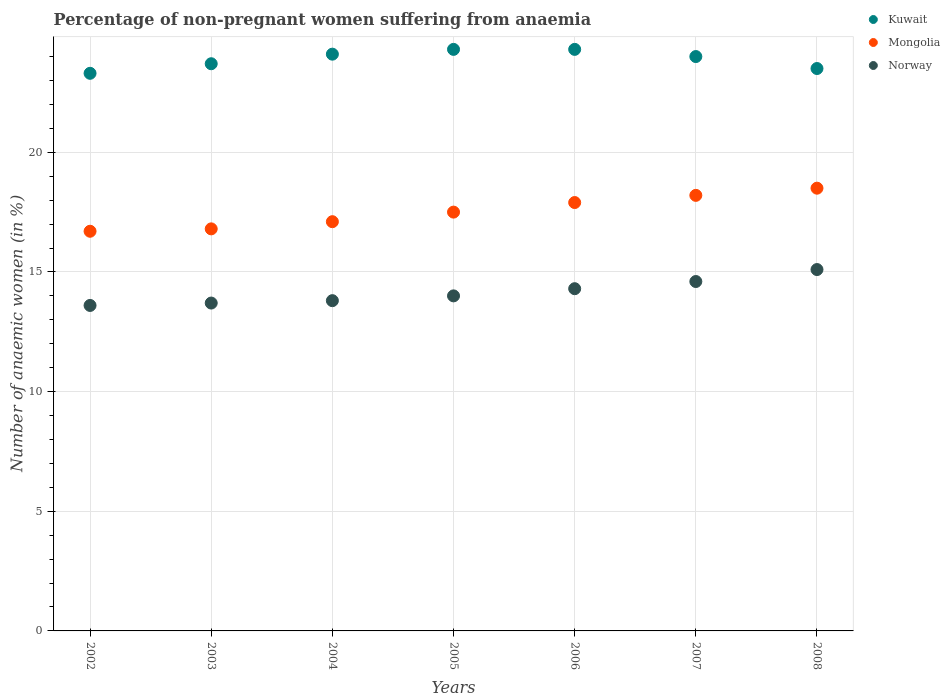How many different coloured dotlines are there?
Your answer should be very brief. 3. Is the number of dotlines equal to the number of legend labels?
Give a very brief answer. Yes. Across all years, what is the minimum percentage of non-pregnant women suffering from anaemia in Norway?
Provide a succinct answer. 13.6. In which year was the percentage of non-pregnant women suffering from anaemia in Mongolia minimum?
Your answer should be compact. 2002. What is the total percentage of non-pregnant women suffering from anaemia in Kuwait in the graph?
Your response must be concise. 167.2. What is the difference between the percentage of non-pregnant women suffering from anaemia in Norway in 2002 and that in 2004?
Your response must be concise. -0.2. What is the difference between the percentage of non-pregnant women suffering from anaemia in Kuwait in 2002 and the percentage of non-pregnant women suffering from anaemia in Norway in 2003?
Offer a terse response. 9.6. What is the average percentage of non-pregnant women suffering from anaemia in Kuwait per year?
Offer a very short reply. 23.89. In the year 2008, what is the difference between the percentage of non-pregnant women suffering from anaemia in Norway and percentage of non-pregnant women suffering from anaemia in Kuwait?
Offer a terse response. -8.4. What is the ratio of the percentage of non-pregnant women suffering from anaemia in Kuwait in 2002 to that in 2003?
Ensure brevity in your answer.  0.98. In how many years, is the percentage of non-pregnant women suffering from anaemia in Norway greater than the average percentage of non-pregnant women suffering from anaemia in Norway taken over all years?
Keep it short and to the point. 3. Is the sum of the percentage of non-pregnant women suffering from anaemia in Norway in 2007 and 2008 greater than the maximum percentage of non-pregnant women suffering from anaemia in Mongolia across all years?
Make the answer very short. Yes. Does the percentage of non-pregnant women suffering from anaemia in Kuwait monotonically increase over the years?
Your answer should be compact. No. How many dotlines are there?
Offer a terse response. 3. What is the difference between two consecutive major ticks on the Y-axis?
Provide a succinct answer. 5. Are the values on the major ticks of Y-axis written in scientific E-notation?
Your answer should be very brief. No. Where does the legend appear in the graph?
Your answer should be very brief. Top right. What is the title of the graph?
Keep it short and to the point. Percentage of non-pregnant women suffering from anaemia. What is the label or title of the X-axis?
Keep it short and to the point. Years. What is the label or title of the Y-axis?
Your answer should be very brief. Number of anaemic women (in %). What is the Number of anaemic women (in %) of Kuwait in 2002?
Offer a terse response. 23.3. What is the Number of anaemic women (in %) in Mongolia in 2002?
Your response must be concise. 16.7. What is the Number of anaemic women (in %) of Kuwait in 2003?
Offer a very short reply. 23.7. What is the Number of anaemic women (in %) of Kuwait in 2004?
Offer a terse response. 24.1. What is the Number of anaemic women (in %) of Norway in 2004?
Offer a terse response. 13.8. What is the Number of anaemic women (in %) in Kuwait in 2005?
Give a very brief answer. 24.3. What is the Number of anaemic women (in %) of Kuwait in 2006?
Keep it short and to the point. 24.3. What is the Number of anaemic women (in %) of Mongolia in 2006?
Your response must be concise. 17.9. What is the Number of anaemic women (in %) of Kuwait in 2007?
Your answer should be very brief. 24. What is the Number of anaemic women (in %) of Norway in 2008?
Keep it short and to the point. 15.1. Across all years, what is the maximum Number of anaemic women (in %) of Kuwait?
Offer a very short reply. 24.3. Across all years, what is the maximum Number of anaemic women (in %) in Mongolia?
Give a very brief answer. 18.5. Across all years, what is the maximum Number of anaemic women (in %) in Norway?
Ensure brevity in your answer.  15.1. Across all years, what is the minimum Number of anaemic women (in %) in Kuwait?
Offer a very short reply. 23.3. Across all years, what is the minimum Number of anaemic women (in %) of Mongolia?
Offer a very short reply. 16.7. What is the total Number of anaemic women (in %) of Kuwait in the graph?
Keep it short and to the point. 167.2. What is the total Number of anaemic women (in %) of Mongolia in the graph?
Offer a terse response. 122.7. What is the total Number of anaemic women (in %) in Norway in the graph?
Your response must be concise. 99.1. What is the difference between the Number of anaemic women (in %) of Norway in 2002 and that in 2003?
Offer a terse response. -0.1. What is the difference between the Number of anaemic women (in %) of Mongolia in 2002 and that in 2005?
Offer a terse response. -0.8. What is the difference between the Number of anaemic women (in %) in Norway in 2002 and that in 2005?
Offer a very short reply. -0.4. What is the difference between the Number of anaemic women (in %) of Kuwait in 2002 and that in 2006?
Give a very brief answer. -1. What is the difference between the Number of anaemic women (in %) of Kuwait in 2002 and that in 2007?
Make the answer very short. -0.7. What is the difference between the Number of anaemic women (in %) in Norway in 2002 and that in 2007?
Your answer should be very brief. -1. What is the difference between the Number of anaemic women (in %) of Kuwait in 2002 and that in 2008?
Make the answer very short. -0.2. What is the difference between the Number of anaemic women (in %) of Norway in 2002 and that in 2008?
Your answer should be very brief. -1.5. What is the difference between the Number of anaemic women (in %) in Kuwait in 2003 and that in 2004?
Your answer should be very brief. -0.4. What is the difference between the Number of anaemic women (in %) of Mongolia in 2003 and that in 2004?
Offer a terse response. -0.3. What is the difference between the Number of anaemic women (in %) of Kuwait in 2003 and that in 2005?
Your answer should be very brief. -0.6. What is the difference between the Number of anaemic women (in %) in Mongolia in 2003 and that in 2005?
Your answer should be very brief. -0.7. What is the difference between the Number of anaemic women (in %) in Norway in 2003 and that in 2005?
Your answer should be compact. -0.3. What is the difference between the Number of anaemic women (in %) of Mongolia in 2003 and that in 2007?
Your response must be concise. -1.4. What is the difference between the Number of anaemic women (in %) in Norway in 2003 and that in 2007?
Provide a succinct answer. -0.9. What is the difference between the Number of anaemic women (in %) in Kuwait in 2004 and that in 2005?
Ensure brevity in your answer.  -0.2. What is the difference between the Number of anaemic women (in %) of Mongolia in 2004 and that in 2005?
Provide a short and direct response. -0.4. What is the difference between the Number of anaemic women (in %) of Norway in 2004 and that in 2006?
Provide a succinct answer. -0.5. What is the difference between the Number of anaemic women (in %) of Kuwait in 2004 and that in 2007?
Make the answer very short. 0.1. What is the difference between the Number of anaemic women (in %) of Mongolia in 2005 and that in 2006?
Give a very brief answer. -0.4. What is the difference between the Number of anaemic women (in %) in Norway in 2005 and that in 2006?
Provide a succinct answer. -0.3. What is the difference between the Number of anaemic women (in %) of Kuwait in 2005 and that in 2007?
Provide a short and direct response. 0.3. What is the difference between the Number of anaemic women (in %) in Mongolia in 2005 and that in 2007?
Your answer should be very brief. -0.7. What is the difference between the Number of anaemic women (in %) of Norway in 2005 and that in 2007?
Offer a terse response. -0.6. What is the difference between the Number of anaemic women (in %) in Mongolia in 2005 and that in 2008?
Offer a very short reply. -1. What is the difference between the Number of anaemic women (in %) of Kuwait in 2006 and that in 2008?
Provide a short and direct response. 0.8. What is the difference between the Number of anaemic women (in %) of Mongolia in 2006 and that in 2008?
Ensure brevity in your answer.  -0.6. What is the difference between the Number of anaemic women (in %) of Norway in 2006 and that in 2008?
Ensure brevity in your answer.  -0.8. What is the difference between the Number of anaemic women (in %) in Norway in 2007 and that in 2008?
Give a very brief answer. -0.5. What is the difference between the Number of anaemic women (in %) in Kuwait in 2002 and the Number of anaemic women (in %) in Norway in 2004?
Provide a succinct answer. 9.5. What is the difference between the Number of anaemic women (in %) in Mongolia in 2002 and the Number of anaemic women (in %) in Norway in 2004?
Give a very brief answer. 2.9. What is the difference between the Number of anaemic women (in %) of Kuwait in 2002 and the Number of anaemic women (in %) of Mongolia in 2005?
Your answer should be very brief. 5.8. What is the difference between the Number of anaemic women (in %) of Kuwait in 2002 and the Number of anaemic women (in %) of Norway in 2005?
Your response must be concise. 9.3. What is the difference between the Number of anaemic women (in %) in Kuwait in 2002 and the Number of anaemic women (in %) in Mongolia in 2006?
Give a very brief answer. 5.4. What is the difference between the Number of anaemic women (in %) of Mongolia in 2002 and the Number of anaemic women (in %) of Norway in 2006?
Your answer should be compact. 2.4. What is the difference between the Number of anaemic women (in %) of Kuwait in 2002 and the Number of anaemic women (in %) of Mongolia in 2007?
Provide a short and direct response. 5.1. What is the difference between the Number of anaemic women (in %) of Kuwait in 2002 and the Number of anaemic women (in %) of Norway in 2007?
Make the answer very short. 8.7. What is the difference between the Number of anaemic women (in %) in Mongolia in 2002 and the Number of anaemic women (in %) in Norway in 2007?
Provide a succinct answer. 2.1. What is the difference between the Number of anaemic women (in %) of Kuwait in 2002 and the Number of anaemic women (in %) of Mongolia in 2008?
Your response must be concise. 4.8. What is the difference between the Number of anaemic women (in %) of Kuwait in 2003 and the Number of anaemic women (in %) of Norway in 2004?
Provide a short and direct response. 9.9. What is the difference between the Number of anaemic women (in %) in Kuwait in 2003 and the Number of anaemic women (in %) in Mongolia in 2005?
Provide a short and direct response. 6.2. What is the difference between the Number of anaemic women (in %) of Mongolia in 2003 and the Number of anaemic women (in %) of Norway in 2005?
Offer a terse response. 2.8. What is the difference between the Number of anaemic women (in %) in Kuwait in 2003 and the Number of anaemic women (in %) in Norway in 2006?
Offer a terse response. 9.4. What is the difference between the Number of anaemic women (in %) in Mongolia in 2003 and the Number of anaemic women (in %) in Norway in 2006?
Your response must be concise. 2.5. What is the difference between the Number of anaemic women (in %) of Mongolia in 2003 and the Number of anaemic women (in %) of Norway in 2007?
Your answer should be compact. 2.2. What is the difference between the Number of anaemic women (in %) in Kuwait in 2003 and the Number of anaemic women (in %) in Mongolia in 2008?
Ensure brevity in your answer.  5.2. What is the difference between the Number of anaemic women (in %) in Mongolia in 2003 and the Number of anaemic women (in %) in Norway in 2008?
Keep it short and to the point. 1.7. What is the difference between the Number of anaemic women (in %) of Kuwait in 2004 and the Number of anaemic women (in %) of Mongolia in 2005?
Provide a short and direct response. 6.6. What is the difference between the Number of anaemic women (in %) of Kuwait in 2004 and the Number of anaemic women (in %) of Mongolia in 2006?
Make the answer very short. 6.2. What is the difference between the Number of anaemic women (in %) of Mongolia in 2004 and the Number of anaemic women (in %) of Norway in 2006?
Offer a very short reply. 2.8. What is the difference between the Number of anaemic women (in %) in Kuwait in 2004 and the Number of anaemic women (in %) in Mongolia in 2007?
Provide a succinct answer. 5.9. What is the difference between the Number of anaemic women (in %) in Kuwait in 2004 and the Number of anaemic women (in %) in Mongolia in 2008?
Offer a terse response. 5.6. What is the difference between the Number of anaemic women (in %) of Kuwait in 2004 and the Number of anaemic women (in %) of Norway in 2008?
Keep it short and to the point. 9. What is the difference between the Number of anaemic women (in %) of Kuwait in 2005 and the Number of anaemic women (in %) of Mongolia in 2007?
Your answer should be very brief. 6.1. What is the difference between the Number of anaemic women (in %) of Kuwait in 2005 and the Number of anaemic women (in %) of Mongolia in 2008?
Provide a short and direct response. 5.8. What is the difference between the Number of anaemic women (in %) in Kuwait in 2005 and the Number of anaemic women (in %) in Norway in 2008?
Your answer should be very brief. 9.2. What is the difference between the Number of anaemic women (in %) in Mongolia in 2006 and the Number of anaemic women (in %) in Norway in 2007?
Your answer should be compact. 3.3. What is the difference between the Number of anaemic women (in %) of Kuwait in 2006 and the Number of anaemic women (in %) of Mongolia in 2008?
Your answer should be very brief. 5.8. What is the difference between the Number of anaemic women (in %) in Mongolia in 2006 and the Number of anaemic women (in %) in Norway in 2008?
Offer a terse response. 2.8. What is the difference between the Number of anaemic women (in %) of Kuwait in 2007 and the Number of anaemic women (in %) of Mongolia in 2008?
Your answer should be very brief. 5.5. What is the difference between the Number of anaemic women (in %) of Kuwait in 2007 and the Number of anaemic women (in %) of Norway in 2008?
Offer a very short reply. 8.9. What is the average Number of anaemic women (in %) in Kuwait per year?
Your response must be concise. 23.89. What is the average Number of anaemic women (in %) of Mongolia per year?
Your response must be concise. 17.53. What is the average Number of anaemic women (in %) of Norway per year?
Ensure brevity in your answer.  14.16. In the year 2002, what is the difference between the Number of anaemic women (in %) of Kuwait and Number of anaemic women (in %) of Mongolia?
Offer a terse response. 6.6. In the year 2003, what is the difference between the Number of anaemic women (in %) in Kuwait and Number of anaemic women (in %) in Mongolia?
Ensure brevity in your answer.  6.9. In the year 2003, what is the difference between the Number of anaemic women (in %) in Mongolia and Number of anaemic women (in %) in Norway?
Make the answer very short. 3.1. In the year 2004, what is the difference between the Number of anaemic women (in %) in Kuwait and Number of anaemic women (in %) in Norway?
Your answer should be very brief. 10.3. In the year 2004, what is the difference between the Number of anaemic women (in %) in Mongolia and Number of anaemic women (in %) in Norway?
Provide a short and direct response. 3.3. In the year 2005, what is the difference between the Number of anaemic women (in %) of Kuwait and Number of anaemic women (in %) of Mongolia?
Provide a short and direct response. 6.8. In the year 2005, what is the difference between the Number of anaemic women (in %) of Kuwait and Number of anaemic women (in %) of Norway?
Keep it short and to the point. 10.3. In the year 2006, what is the difference between the Number of anaemic women (in %) in Mongolia and Number of anaemic women (in %) in Norway?
Your answer should be very brief. 3.6. In the year 2007, what is the difference between the Number of anaemic women (in %) of Kuwait and Number of anaemic women (in %) of Mongolia?
Make the answer very short. 5.8. In the year 2008, what is the difference between the Number of anaemic women (in %) of Kuwait and Number of anaemic women (in %) of Norway?
Provide a short and direct response. 8.4. In the year 2008, what is the difference between the Number of anaemic women (in %) of Mongolia and Number of anaemic women (in %) of Norway?
Give a very brief answer. 3.4. What is the ratio of the Number of anaemic women (in %) of Kuwait in 2002 to that in 2003?
Your response must be concise. 0.98. What is the ratio of the Number of anaemic women (in %) of Mongolia in 2002 to that in 2003?
Offer a terse response. 0.99. What is the ratio of the Number of anaemic women (in %) in Kuwait in 2002 to that in 2004?
Ensure brevity in your answer.  0.97. What is the ratio of the Number of anaemic women (in %) of Mongolia in 2002 to that in 2004?
Your answer should be very brief. 0.98. What is the ratio of the Number of anaemic women (in %) of Norway in 2002 to that in 2004?
Provide a short and direct response. 0.99. What is the ratio of the Number of anaemic women (in %) in Kuwait in 2002 to that in 2005?
Offer a terse response. 0.96. What is the ratio of the Number of anaemic women (in %) in Mongolia in 2002 to that in 2005?
Give a very brief answer. 0.95. What is the ratio of the Number of anaemic women (in %) of Norway in 2002 to that in 2005?
Provide a succinct answer. 0.97. What is the ratio of the Number of anaemic women (in %) in Kuwait in 2002 to that in 2006?
Provide a succinct answer. 0.96. What is the ratio of the Number of anaemic women (in %) of Mongolia in 2002 to that in 2006?
Your answer should be compact. 0.93. What is the ratio of the Number of anaemic women (in %) of Norway in 2002 to that in 2006?
Offer a very short reply. 0.95. What is the ratio of the Number of anaemic women (in %) of Kuwait in 2002 to that in 2007?
Provide a short and direct response. 0.97. What is the ratio of the Number of anaemic women (in %) in Mongolia in 2002 to that in 2007?
Ensure brevity in your answer.  0.92. What is the ratio of the Number of anaemic women (in %) of Norway in 2002 to that in 2007?
Provide a short and direct response. 0.93. What is the ratio of the Number of anaemic women (in %) in Kuwait in 2002 to that in 2008?
Ensure brevity in your answer.  0.99. What is the ratio of the Number of anaemic women (in %) of Mongolia in 2002 to that in 2008?
Provide a short and direct response. 0.9. What is the ratio of the Number of anaemic women (in %) of Norway in 2002 to that in 2008?
Offer a very short reply. 0.9. What is the ratio of the Number of anaemic women (in %) of Kuwait in 2003 to that in 2004?
Give a very brief answer. 0.98. What is the ratio of the Number of anaemic women (in %) of Mongolia in 2003 to that in 2004?
Your answer should be very brief. 0.98. What is the ratio of the Number of anaemic women (in %) in Norway in 2003 to that in 2004?
Offer a terse response. 0.99. What is the ratio of the Number of anaemic women (in %) of Kuwait in 2003 to that in 2005?
Provide a succinct answer. 0.98. What is the ratio of the Number of anaemic women (in %) in Norway in 2003 to that in 2005?
Offer a terse response. 0.98. What is the ratio of the Number of anaemic women (in %) in Kuwait in 2003 to that in 2006?
Offer a very short reply. 0.98. What is the ratio of the Number of anaemic women (in %) in Mongolia in 2003 to that in 2006?
Give a very brief answer. 0.94. What is the ratio of the Number of anaemic women (in %) of Norway in 2003 to that in 2006?
Provide a succinct answer. 0.96. What is the ratio of the Number of anaemic women (in %) in Kuwait in 2003 to that in 2007?
Ensure brevity in your answer.  0.99. What is the ratio of the Number of anaemic women (in %) of Mongolia in 2003 to that in 2007?
Keep it short and to the point. 0.92. What is the ratio of the Number of anaemic women (in %) in Norway in 2003 to that in 2007?
Provide a succinct answer. 0.94. What is the ratio of the Number of anaemic women (in %) in Kuwait in 2003 to that in 2008?
Keep it short and to the point. 1.01. What is the ratio of the Number of anaemic women (in %) in Mongolia in 2003 to that in 2008?
Offer a terse response. 0.91. What is the ratio of the Number of anaemic women (in %) of Norway in 2003 to that in 2008?
Keep it short and to the point. 0.91. What is the ratio of the Number of anaemic women (in %) of Mongolia in 2004 to that in 2005?
Offer a very short reply. 0.98. What is the ratio of the Number of anaemic women (in %) in Norway in 2004 to that in 2005?
Your answer should be very brief. 0.99. What is the ratio of the Number of anaemic women (in %) in Kuwait in 2004 to that in 2006?
Give a very brief answer. 0.99. What is the ratio of the Number of anaemic women (in %) in Mongolia in 2004 to that in 2006?
Your response must be concise. 0.96. What is the ratio of the Number of anaemic women (in %) of Norway in 2004 to that in 2006?
Your answer should be compact. 0.96. What is the ratio of the Number of anaemic women (in %) of Kuwait in 2004 to that in 2007?
Offer a very short reply. 1. What is the ratio of the Number of anaemic women (in %) in Mongolia in 2004 to that in 2007?
Give a very brief answer. 0.94. What is the ratio of the Number of anaemic women (in %) of Norway in 2004 to that in 2007?
Provide a short and direct response. 0.95. What is the ratio of the Number of anaemic women (in %) of Kuwait in 2004 to that in 2008?
Provide a short and direct response. 1.03. What is the ratio of the Number of anaemic women (in %) of Mongolia in 2004 to that in 2008?
Provide a succinct answer. 0.92. What is the ratio of the Number of anaemic women (in %) of Norway in 2004 to that in 2008?
Make the answer very short. 0.91. What is the ratio of the Number of anaemic women (in %) of Kuwait in 2005 to that in 2006?
Your response must be concise. 1. What is the ratio of the Number of anaemic women (in %) in Mongolia in 2005 to that in 2006?
Keep it short and to the point. 0.98. What is the ratio of the Number of anaemic women (in %) of Norway in 2005 to that in 2006?
Ensure brevity in your answer.  0.98. What is the ratio of the Number of anaemic women (in %) of Kuwait in 2005 to that in 2007?
Ensure brevity in your answer.  1.01. What is the ratio of the Number of anaemic women (in %) in Mongolia in 2005 to that in 2007?
Your response must be concise. 0.96. What is the ratio of the Number of anaemic women (in %) of Norway in 2005 to that in 2007?
Your answer should be very brief. 0.96. What is the ratio of the Number of anaemic women (in %) of Kuwait in 2005 to that in 2008?
Give a very brief answer. 1.03. What is the ratio of the Number of anaemic women (in %) in Mongolia in 2005 to that in 2008?
Keep it short and to the point. 0.95. What is the ratio of the Number of anaemic women (in %) of Norway in 2005 to that in 2008?
Offer a terse response. 0.93. What is the ratio of the Number of anaemic women (in %) of Kuwait in 2006 to that in 2007?
Offer a very short reply. 1.01. What is the ratio of the Number of anaemic women (in %) in Mongolia in 2006 to that in 2007?
Your answer should be very brief. 0.98. What is the ratio of the Number of anaemic women (in %) in Norway in 2006 to that in 2007?
Keep it short and to the point. 0.98. What is the ratio of the Number of anaemic women (in %) of Kuwait in 2006 to that in 2008?
Provide a short and direct response. 1.03. What is the ratio of the Number of anaemic women (in %) in Mongolia in 2006 to that in 2008?
Keep it short and to the point. 0.97. What is the ratio of the Number of anaemic women (in %) in Norway in 2006 to that in 2008?
Provide a succinct answer. 0.95. What is the ratio of the Number of anaemic women (in %) in Kuwait in 2007 to that in 2008?
Ensure brevity in your answer.  1.02. What is the ratio of the Number of anaemic women (in %) in Mongolia in 2007 to that in 2008?
Your answer should be compact. 0.98. What is the ratio of the Number of anaemic women (in %) of Norway in 2007 to that in 2008?
Keep it short and to the point. 0.97. What is the difference between the highest and the second highest Number of anaemic women (in %) of Kuwait?
Provide a short and direct response. 0. What is the difference between the highest and the second highest Number of anaemic women (in %) in Norway?
Make the answer very short. 0.5. What is the difference between the highest and the lowest Number of anaemic women (in %) of Mongolia?
Offer a very short reply. 1.8. 